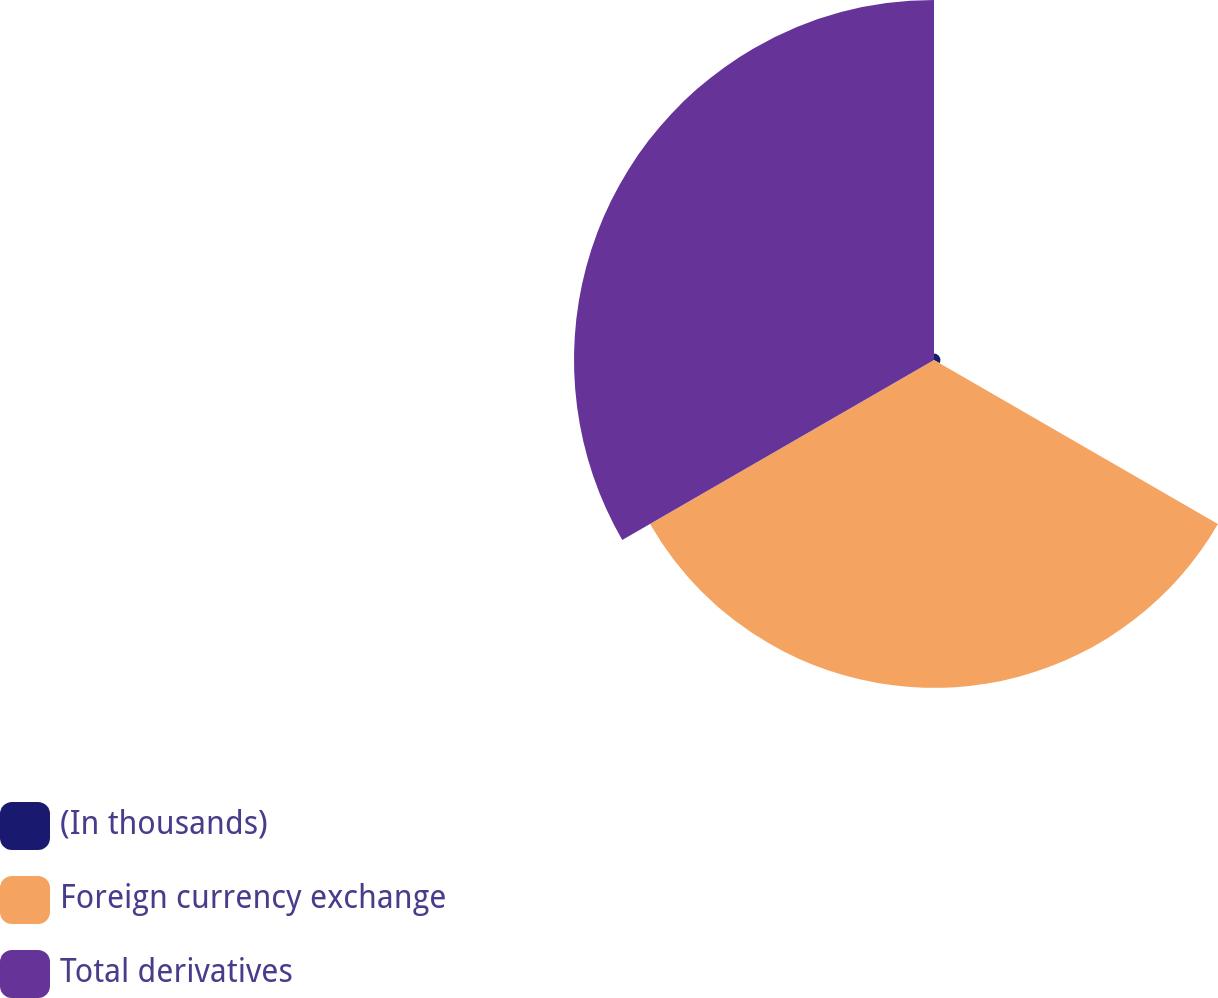Convert chart to OTSL. <chart><loc_0><loc_0><loc_500><loc_500><pie_chart><fcel>(In thousands)<fcel>Foreign currency exchange<fcel>Total derivatives<nl><fcel>0.92%<fcel>47.22%<fcel>51.85%<nl></chart> 